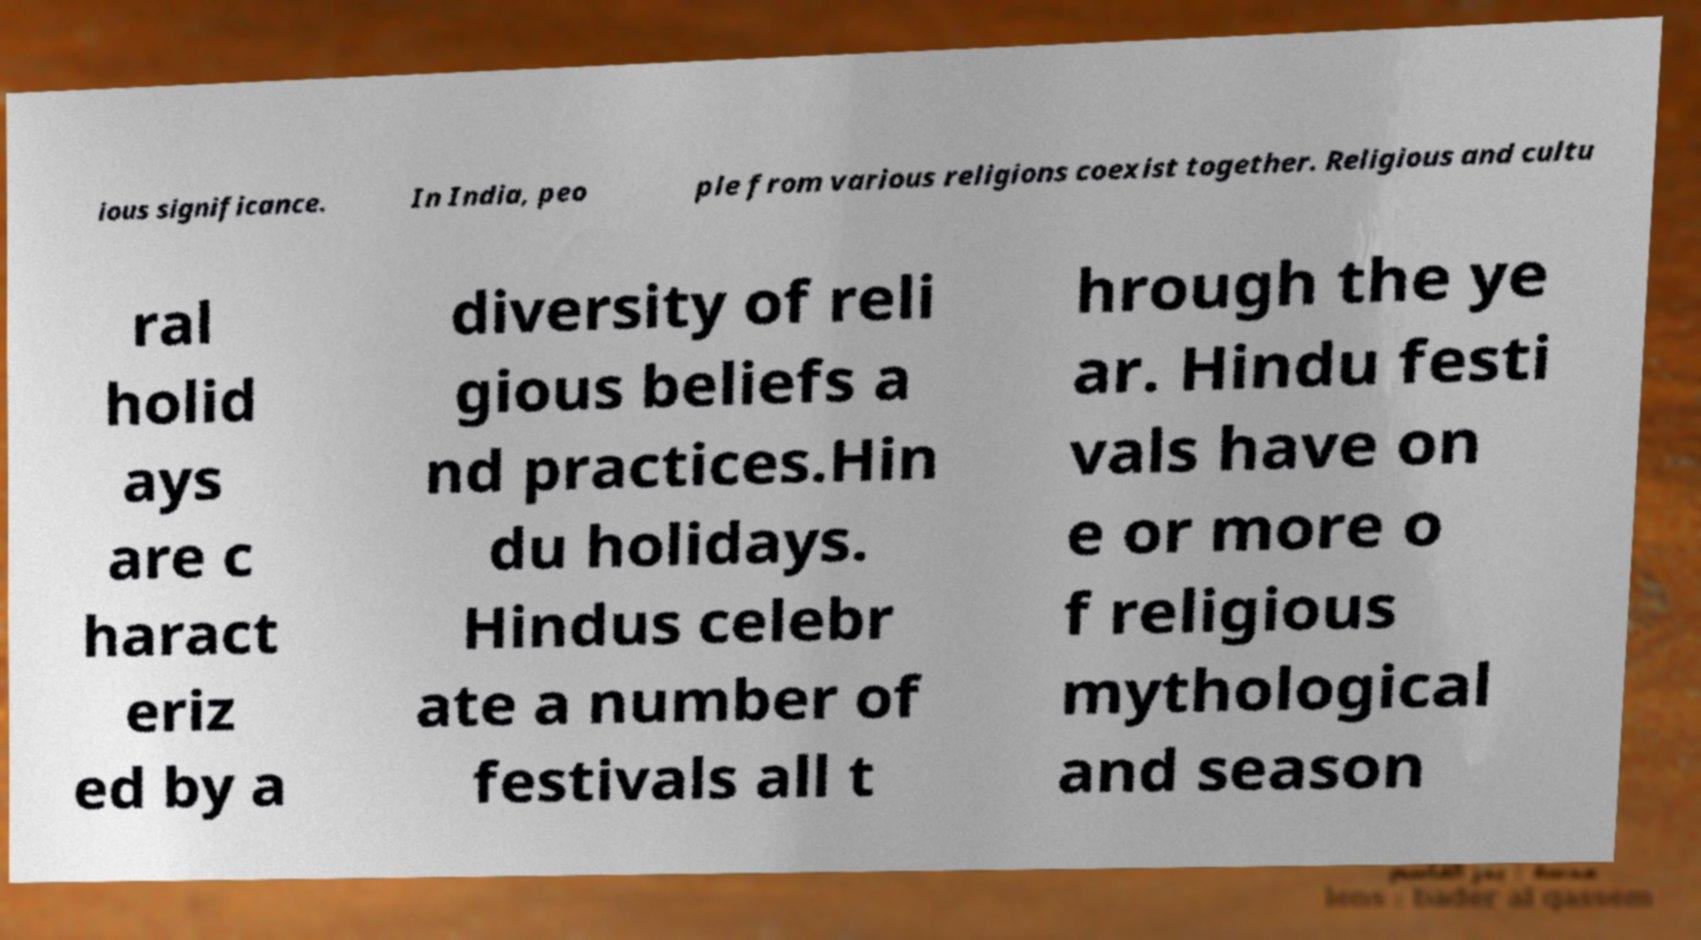Please read and relay the text visible in this image. What does it say? ious significance. In India, peo ple from various religions coexist together. Religious and cultu ral holid ays are c haract eriz ed by a diversity of reli gious beliefs a nd practices.Hin du holidays. Hindus celebr ate a number of festivals all t hrough the ye ar. Hindu festi vals have on e or more o f religious mythological and season 